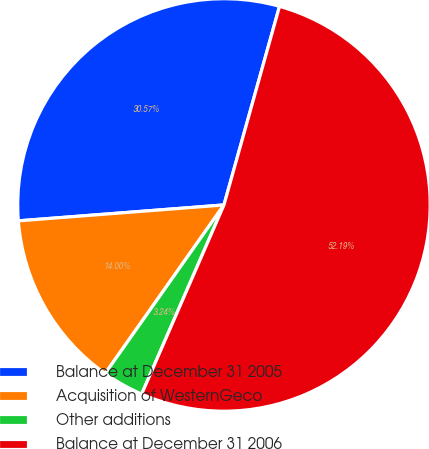<chart> <loc_0><loc_0><loc_500><loc_500><pie_chart><fcel>Balance at December 31 2005<fcel>Acquisition of WesternGeco<fcel>Other additions<fcel>Balance at December 31 2006<nl><fcel>30.57%<fcel>14.0%<fcel>3.24%<fcel>52.19%<nl></chart> 